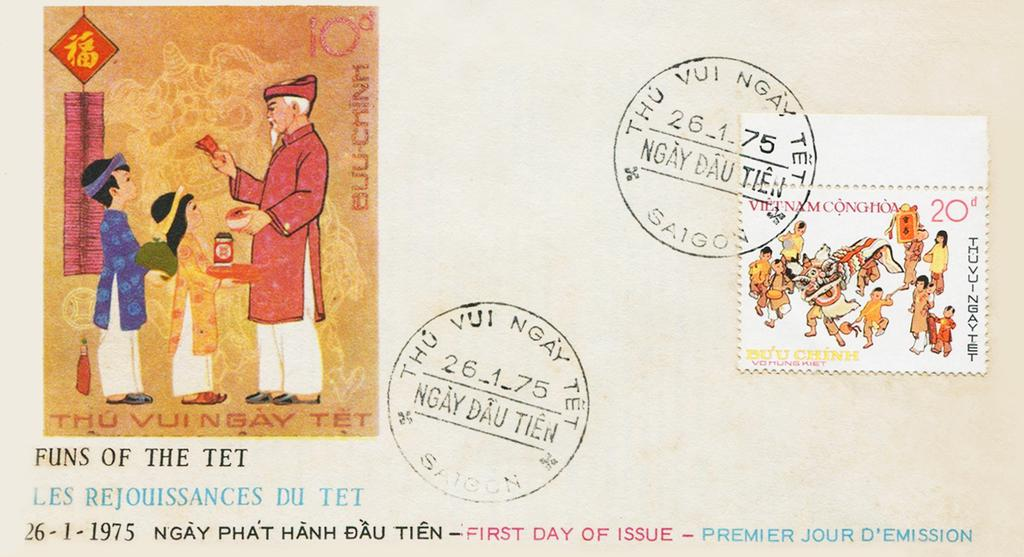<image>
Summarize the visual content of the image. A postcard with "Funs of the Tet" written under a picture. 